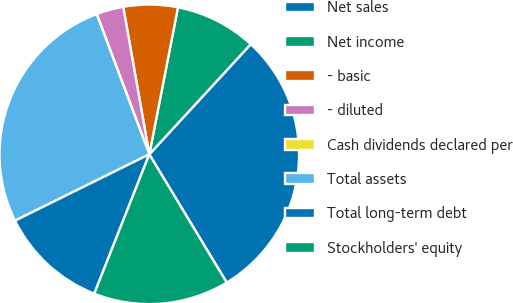<chart> <loc_0><loc_0><loc_500><loc_500><pie_chart><fcel>Net sales<fcel>Net income<fcel>- basic<fcel>- diluted<fcel>Cash dividends declared per<fcel>Total assets<fcel>Total long-term debt<fcel>Stockholders' equity<nl><fcel>29.51%<fcel>8.78%<fcel>5.85%<fcel>2.93%<fcel>0.0%<fcel>26.59%<fcel>11.71%<fcel>14.63%<nl></chart> 